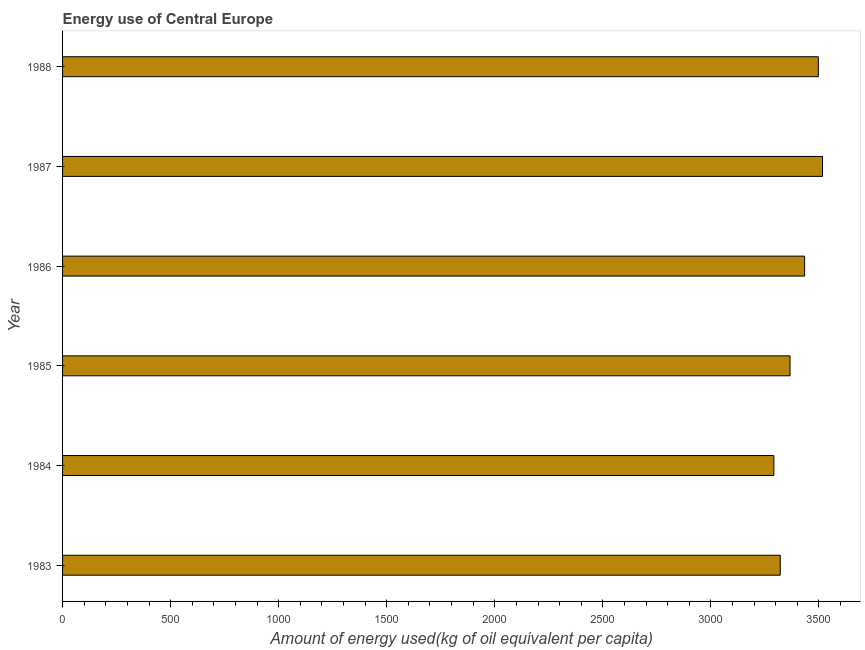What is the title of the graph?
Provide a succinct answer. Energy use of Central Europe. What is the label or title of the X-axis?
Give a very brief answer. Amount of energy used(kg of oil equivalent per capita). What is the amount of energy used in 1983?
Offer a terse response. 3320.97. Across all years, what is the maximum amount of energy used?
Your response must be concise. 3516.41. Across all years, what is the minimum amount of energy used?
Keep it short and to the point. 3291.37. In which year was the amount of energy used maximum?
Offer a very short reply. 1987. What is the sum of the amount of energy used?
Your response must be concise. 2.04e+04. What is the difference between the amount of energy used in 1985 and 1988?
Your answer should be very brief. -130.9. What is the average amount of energy used per year?
Your answer should be compact. 3404.3. What is the median amount of energy used?
Your answer should be compact. 3399.97. Do a majority of the years between 1986 and 1983 (inclusive) have amount of energy used greater than 2400 kg?
Make the answer very short. Yes. Is the difference between the amount of energy used in 1983 and 1985 greater than the difference between any two years?
Offer a terse response. No. What is the difference between the highest and the second highest amount of energy used?
Provide a short and direct response. 19.3. What is the difference between the highest and the lowest amount of energy used?
Your answer should be compact. 225.04. In how many years, is the amount of energy used greater than the average amount of energy used taken over all years?
Your answer should be very brief. 3. How many bars are there?
Give a very brief answer. 6. Are all the bars in the graph horizontal?
Your answer should be compact. Yes. What is the difference between two consecutive major ticks on the X-axis?
Your answer should be compact. 500. Are the values on the major ticks of X-axis written in scientific E-notation?
Provide a succinct answer. No. What is the Amount of energy used(kg of oil equivalent per capita) of 1983?
Offer a terse response. 3320.97. What is the Amount of energy used(kg of oil equivalent per capita) of 1984?
Your answer should be compact. 3291.37. What is the Amount of energy used(kg of oil equivalent per capita) in 1985?
Ensure brevity in your answer.  3366.21. What is the Amount of energy used(kg of oil equivalent per capita) in 1986?
Your response must be concise. 3433.73. What is the Amount of energy used(kg of oil equivalent per capita) of 1987?
Provide a succinct answer. 3516.41. What is the Amount of energy used(kg of oil equivalent per capita) of 1988?
Offer a terse response. 3497.12. What is the difference between the Amount of energy used(kg of oil equivalent per capita) in 1983 and 1984?
Keep it short and to the point. 29.59. What is the difference between the Amount of energy used(kg of oil equivalent per capita) in 1983 and 1985?
Your answer should be very brief. -45.25. What is the difference between the Amount of energy used(kg of oil equivalent per capita) in 1983 and 1986?
Your answer should be very brief. -112.76. What is the difference between the Amount of energy used(kg of oil equivalent per capita) in 1983 and 1987?
Offer a terse response. -195.45. What is the difference between the Amount of energy used(kg of oil equivalent per capita) in 1983 and 1988?
Your answer should be very brief. -176.15. What is the difference between the Amount of energy used(kg of oil equivalent per capita) in 1984 and 1985?
Offer a very short reply. -74.84. What is the difference between the Amount of energy used(kg of oil equivalent per capita) in 1984 and 1986?
Give a very brief answer. -142.36. What is the difference between the Amount of energy used(kg of oil equivalent per capita) in 1984 and 1987?
Offer a terse response. -225.04. What is the difference between the Amount of energy used(kg of oil equivalent per capita) in 1984 and 1988?
Give a very brief answer. -205.74. What is the difference between the Amount of energy used(kg of oil equivalent per capita) in 1985 and 1986?
Offer a very short reply. -67.52. What is the difference between the Amount of energy used(kg of oil equivalent per capita) in 1985 and 1987?
Keep it short and to the point. -150.2. What is the difference between the Amount of energy used(kg of oil equivalent per capita) in 1985 and 1988?
Your response must be concise. -130.9. What is the difference between the Amount of energy used(kg of oil equivalent per capita) in 1986 and 1987?
Offer a very short reply. -82.68. What is the difference between the Amount of energy used(kg of oil equivalent per capita) in 1986 and 1988?
Keep it short and to the point. -63.38. What is the difference between the Amount of energy used(kg of oil equivalent per capita) in 1987 and 1988?
Offer a terse response. 19.3. What is the ratio of the Amount of energy used(kg of oil equivalent per capita) in 1983 to that in 1984?
Your response must be concise. 1.01. What is the ratio of the Amount of energy used(kg of oil equivalent per capita) in 1983 to that in 1985?
Offer a terse response. 0.99. What is the ratio of the Amount of energy used(kg of oil equivalent per capita) in 1983 to that in 1987?
Your answer should be very brief. 0.94. What is the ratio of the Amount of energy used(kg of oil equivalent per capita) in 1984 to that in 1986?
Your answer should be compact. 0.96. What is the ratio of the Amount of energy used(kg of oil equivalent per capita) in 1984 to that in 1987?
Provide a short and direct response. 0.94. What is the ratio of the Amount of energy used(kg of oil equivalent per capita) in 1984 to that in 1988?
Offer a terse response. 0.94. What is the ratio of the Amount of energy used(kg of oil equivalent per capita) in 1985 to that in 1986?
Offer a very short reply. 0.98. What is the ratio of the Amount of energy used(kg of oil equivalent per capita) in 1985 to that in 1987?
Give a very brief answer. 0.96. What is the ratio of the Amount of energy used(kg of oil equivalent per capita) in 1986 to that in 1987?
Make the answer very short. 0.98. 